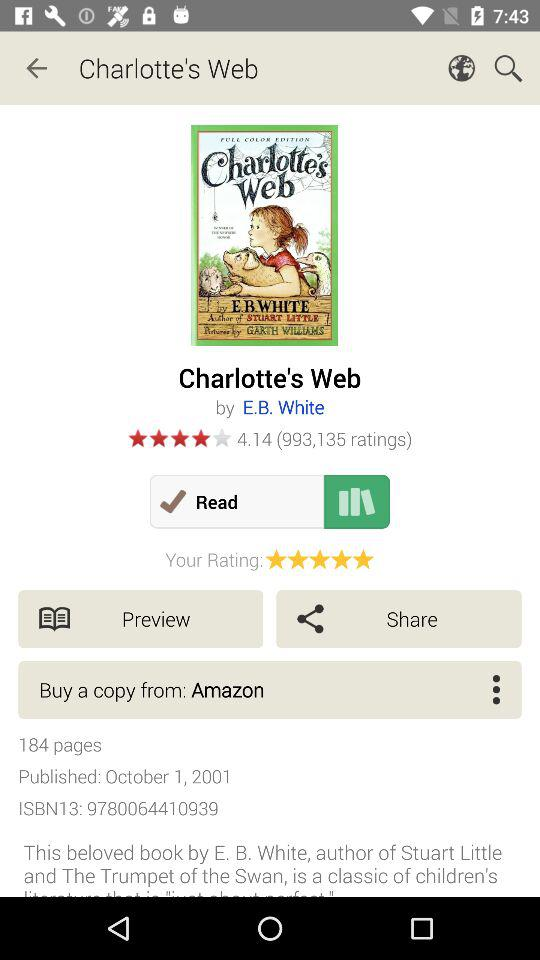How many pages in total are there? There are 184 pages in total. 